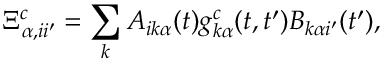Convert formula to latex. <formula><loc_0><loc_0><loc_500><loc_500>\Xi _ { \alpha , i i ^ { \prime } } ^ { c } = \sum _ { k } A _ { i k \alpha } ( t ) g _ { k \alpha } ^ { c } ( t , t ^ { \prime } ) B _ { k \alpha i ^ { \prime } } ( t ^ { \prime } ) ,</formula> 